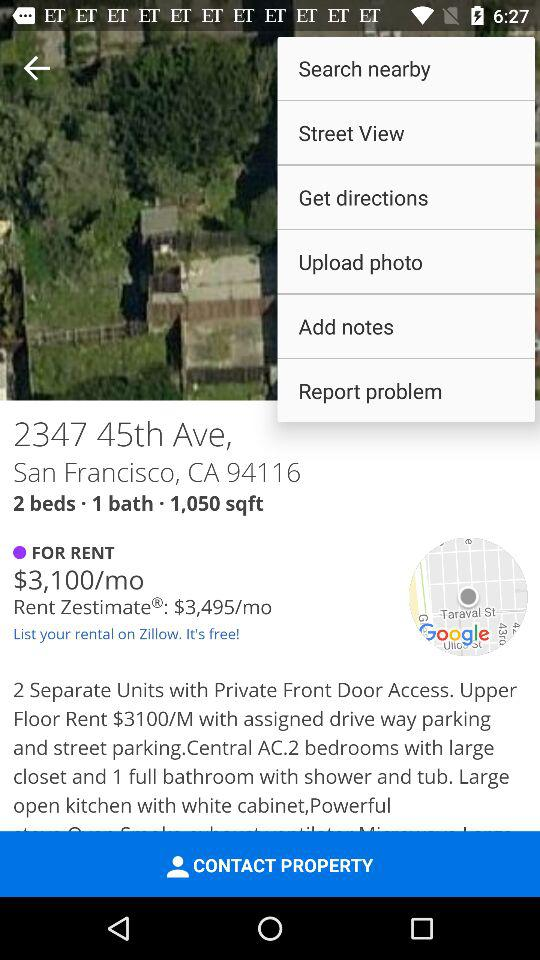How many sqft is the property? The property is in 1,050 square feet. 